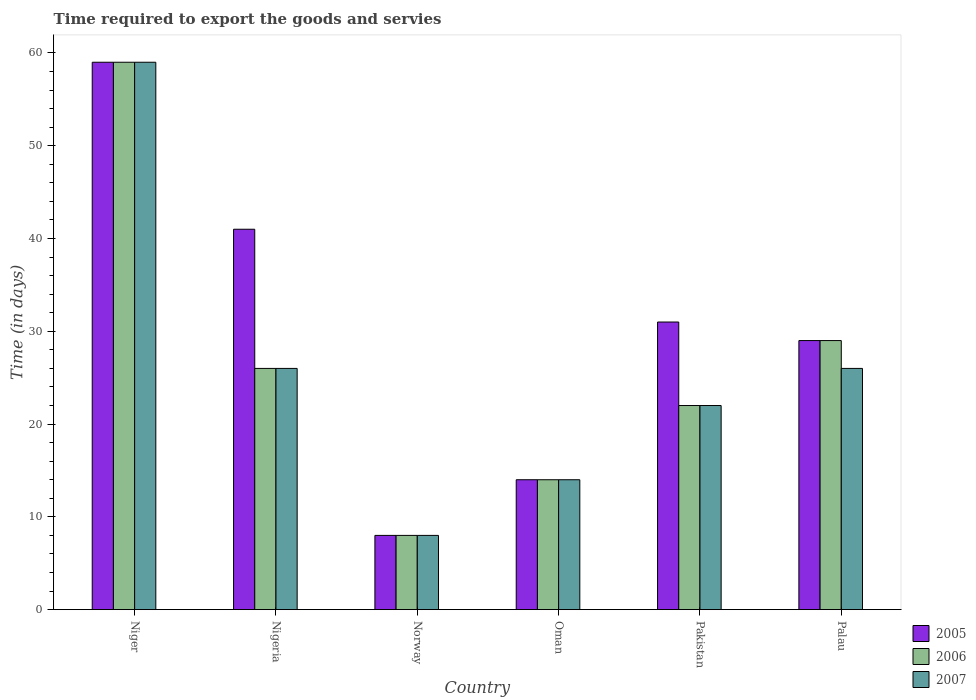How many different coloured bars are there?
Provide a short and direct response. 3. Are the number of bars per tick equal to the number of legend labels?
Ensure brevity in your answer.  Yes. Are the number of bars on each tick of the X-axis equal?
Keep it short and to the point. Yes. How many bars are there on the 4th tick from the right?
Your response must be concise. 3. What is the label of the 2nd group of bars from the left?
Your response must be concise. Nigeria. In which country was the number of days required to export the goods and services in 2006 maximum?
Provide a short and direct response. Niger. In which country was the number of days required to export the goods and services in 2006 minimum?
Provide a succinct answer. Norway. What is the total number of days required to export the goods and services in 2007 in the graph?
Your answer should be very brief. 155. What is the difference between the number of days required to export the goods and services in 2007 in Norway and that in Oman?
Provide a succinct answer. -6. What is the difference between the number of days required to export the goods and services in 2007 in Norway and the number of days required to export the goods and services in 2005 in Nigeria?
Make the answer very short. -33. What is the average number of days required to export the goods and services in 2006 per country?
Provide a succinct answer. 26.33. What is the difference between the number of days required to export the goods and services of/in 2006 and number of days required to export the goods and services of/in 2005 in Oman?
Provide a succinct answer. 0. In how many countries, is the number of days required to export the goods and services in 2005 greater than 22 days?
Offer a terse response. 4. What is the ratio of the number of days required to export the goods and services in 2007 in Oman to that in Pakistan?
Provide a succinct answer. 0.64. Is the number of days required to export the goods and services in 2007 in Niger less than that in Oman?
Offer a very short reply. No. Is the difference between the number of days required to export the goods and services in 2006 in Niger and Palau greater than the difference between the number of days required to export the goods and services in 2005 in Niger and Palau?
Make the answer very short. No. What is the difference between the highest and the second highest number of days required to export the goods and services in 2007?
Provide a short and direct response. -33. What is the difference between the highest and the lowest number of days required to export the goods and services in 2006?
Offer a terse response. 51. What does the 1st bar from the right in Palau represents?
Ensure brevity in your answer.  2007. Is it the case that in every country, the sum of the number of days required to export the goods and services in 2007 and number of days required to export the goods and services in 2005 is greater than the number of days required to export the goods and services in 2006?
Offer a very short reply. Yes. How many bars are there?
Ensure brevity in your answer.  18. How many countries are there in the graph?
Your answer should be very brief. 6. What is the difference between two consecutive major ticks on the Y-axis?
Offer a very short reply. 10. Are the values on the major ticks of Y-axis written in scientific E-notation?
Provide a succinct answer. No. Does the graph contain any zero values?
Give a very brief answer. No. Does the graph contain grids?
Give a very brief answer. No. Where does the legend appear in the graph?
Give a very brief answer. Bottom right. How are the legend labels stacked?
Offer a terse response. Vertical. What is the title of the graph?
Keep it short and to the point. Time required to export the goods and servies. Does "2002" appear as one of the legend labels in the graph?
Provide a short and direct response. No. What is the label or title of the X-axis?
Give a very brief answer. Country. What is the label or title of the Y-axis?
Give a very brief answer. Time (in days). What is the Time (in days) in 2005 in Niger?
Keep it short and to the point. 59. What is the Time (in days) of 2006 in Niger?
Give a very brief answer. 59. What is the Time (in days) in 2006 in Nigeria?
Give a very brief answer. 26. What is the Time (in days) of 2007 in Norway?
Your answer should be compact. 8. What is the Time (in days) of 2006 in Oman?
Your answer should be compact. 14. What is the Time (in days) in 2005 in Pakistan?
Offer a very short reply. 31. What is the Time (in days) of 2005 in Palau?
Your answer should be very brief. 29. Across all countries, what is the maximum Time (in days) of 2006?
Your response must be concise. 59. Across all countries, what is the minimum Time (in days) of 2005?
Your answer should be very brief. 8. Across all countries, what is the minimum Time (in days) of 2006?
Provide a short and direct response. 8. What is the total Time (in days) of 2005 in the graph?
Keep it short and to the point. 182. What is the total Time (in days) of 2006 in the graph?
Ensure brevity in your answer.  158. What is the total Time (in days) of 2007 in the graph?
Offer a very short reply. 155. What is the difference between the Time (in days) of 2006 in Niger and that in Nigeria?
Provide a short and direct response. 33. What is the difference between the Time (in days) of 2005 in Niger and that in Norway?
Ensure brevity in your answer.  51. What is the difference between the Time (in days) of 2006 in Niger and that in Norway?
Provide a short and direct response. 51. What is the difference between the Time (in days) of 2006 in Niger and that in Oman?
Your answer should be compact. 45. What is the difference between the Time (in days) in 2005 in Niger and that in Pakistan?
Make the answer very short. 28. What is the difference between the Time (in days) in 2006 in Niger and that in Pakistan?
Offer a very short reply. 37. What is the difference between the Time (in days) of 2007 in Niger and that in Pakistan?
Make the answer very short. 37. What is the difference between the Time (in days) in 2006 in Niger and that in Palau?
Provide a succinct answer. 30. What is the difference between the Time (in days) in 2005 in Nigeria and that in Norway?
Your response must be concise. 33. What is the difference between the Time (in days) in 2006 in Nigeria and that in Norway?
Give a very brief answer. 18. What is the difference between the Time (in days) of 2007 in Nigeria and that in Norway?
Keep it short and to the point. 18. What is the difference between the Time (in days) in 2005 in Nigeria and that in Oman?
Offer a very short reply. 27. What is the difference between the Time (in days) of 2005 in Nigeria and that in Pakistan?
Your answer should be compact. 10. What is the difference between the Time (in days) of 2006 in Nigeria and that in Pakistan?
Offer a terse response. 4. What is the difference between the Time (in days) of 2007 in Nigeria and that in Pakistan?
Ensure brevity in your answer.  4. What is the difference between the Time (in days) of 2006 in Nigeria and that in Palau?
Your response must be concise. -3. What is the difference between the Time (in days) in 2005 in Norway and that in Oman?
Offer a very short reply. -6. What is the difference between the Time (in days) in 2006 in Norway and that in Oman?
Offer a terse response. -6. What is the difference between the Time (in days) of 2007 in Norway and that in Oman?
Provide a short and direct response. -6. What is the difference between the Time (in days) in 2006 in Norway and that in Pakistan?
Offer a very short reply. -14. What is the difference between the Time (in days) of 2005 in Norway and that in Palau?
Give a very brief answer. -21. What is the difference between the Time (in days) in 2007 in Norway and that in Palau?
Provide a short and direct response. -18. What is the difference between the Time (in days) of 2006 in Oman and that in Palau?
Your answer should be compact. -15. What is the difference between the Time (in days) of 2006 in Pakistan and that in Palau?
Provide a short and direct response. -7. What is the difference between the Time (in days) in 2007 in Pakistan and that in Palau?
Provide a short and direct response. -4. What is the difference between the Time (in days) in 2006 in Niger and the Time (in days) in 2007 in Nigeria?
Ensure brevity in your answer.  33. What is the difference between the Time (in days) of 2005 in Niger and the Time (in days) of 2006 in Norway?
Your response must be concise. 51. What is the difference between the Time (in days) in 2006 in Niger and the Time (in days) in 2007 in Norway?
Provide a short and direct response. 51. What is the difference between the Time (in days) of 2005 in Niger and the Time (in days) of 2006 in Oman?
Ensure brevity in your answer.  45. What is the difference between the Time (in days) in 2005 in Niger and the Time (in days) in 2007 in Oman?
Offer a terse response. 45. What is the difference between the Time (in days) of 2005 in Niger and the Time (in days) of 2007 in Pakistan?
Your response must be concise. 37. What is the difference between the Time (in days) of 2005 in Niger and the Time (in days) of 2007 in Palau?
Provide a succinct answer. 33. What is the difference between the Time (in days) of 2005 in Nigeria and the Time (in days) of 2006 in Norway?
Provide a short and direct response. 33. What is the difference between the Time (in days) in 2005 in Nigeria and the Time (in days) in 2007 in Norway?
Offer a very short reply. 33. What is the difference between the Time (in days) of 2006 in Nigeria and the Time (in days) of 2007 in Norway?
Make the answer very short. 18. What is the difference between the Time (in days) of 2005 in Nigeria and the Time (in days) of 2007 in Pakistan?
Your answer should be very brief. 19. What is the difference between the Time (in days) of 2005 in Nigeria and the Time (in days) of 2007 in Palau?
Your answer should be compact. 15. What is the difference between the Time (in days) of 2006 in Nigeria and the Time (in days) of 2007 in Palau?
Keep it short and to the point. 0. What is the difference between the Time (in days) of 2005 in Norway and the Time (in days) of 2007 in Oman?
Offer a very short reply. -6. What is the difference between the Time (in days) of 2005 in Norway and the Time (in days) of 2007 in Pakistan?
Your answer should be compact. -14. What is the difference between the Time (in days) of 2006 in Norway and the Time (in days) of 2007 in Pakistan?
Give a very brief answer. -14. What is the difference between the Time (in days) of 2005 in Norway and the Time (in days) of 2007 in Palau?
Your response must be concise. -18. What is the difference between the Time (in days) in 2005 in Oman and the Time (in days) in 2006 in Pakistan?
Offer a very short reply. -8. What is the difference between the Time (in days) in 2005 in Oman and the Time (in days) in 2007 in Pakistan?
Your answer should be compact. -8. What is the difference between the Time (in days) in 2006 in Oman and the Time (in days) in 2007 in Pakistan?
Offer a very short reply. -8. What is the difference between the Time (in days) in 2005 in Oman and the Time (in days) in 2006 in Palau?
Provide a succinct answer. -15. What is the difference between the Time (in days) in 2006 in Oman and the Time (in days) in 2007 in Palau?
Offer a terse response. -12. What is the difference between the Time (in days) of 2005 in Pakistan and the Time (in days) of 2006 in Palau?
Provide a succinct answer. 2. What is the difference between the Time (in days) of 2006 in Pakistan and the Time (in days) of 2007 in Palau?
Make the answer very short. -4. What is the average Time (in days) in 2005 per country?
Give a very brief answer. 30.33. What is the average Time (in days) of 2006 per country?
Offer a terse response. 26.33. What is the average Time (in days) of 2007 per country?
Provide a succinct answer. 25.83. What is the difference between the Time (in days) of 2005 and Time (in days) of 2006 in Niger?
Offer a terse response. 0. What is the difference between the Time (in days) of 2005 and Time (in days) of 2007 in Niger?
Your answer should be very brief. 0. What is the difference between the Time (in days) of 2006 and Time (in days) of 2007 in Niger?
Your answer should be very brief. 0. What is the difference between the Time (in days) of 2005 and Time (in days) of 2006 in Nigeria?
Keep it short and to the point. 15. What is the difference between the Time (in days) of 2005 and Time (in days) of 2007 in Nigeria?
Offer a terse response. 15. What is the difference between the Time (in days) of 2005 and Time (in days) of 2006 in Norway?
Provide a succinct answer. 0. What is the difference between the Time (in days) in 2005 and Time (in days) in 2007 in Norway?
Offer a very short reply. 0. What is the difference between the Time (in days) of 2006 and Time (in days) of 2007 in Norway?
Offer a very short reply. 0. What is the difference between the Time (in days) in 2005 and Time (in days) in 2007 in Oman?
Make the answer very short. 0. What is the difference between the Time (in days) in 2005 and Time (in days) in 2006 in Pakistan?
Ensure brevity in your answer.  9. What is the difference between the Time (in days) in 2005 and Time (in days) in 2007 in Pakistan?
Your answer should be very brief. 9. What is the ratio of the Time (in days) of 2005 in Niger to that in Nigeria?
Keep it short and to the point. 1.44. What is the ratio of the Time (in days) of 2006 in Niger to that in Nigeria?
Your answer should be very brief. 2.27. What is the ratio of the Time (in days) in 2007 in Niger to that in Nigeria?
Provide a short and direct response. 2.27. What is the ratio of the Time (in days) of 2005 in Niger to that in Norway?
Your response must be concise. 7.38. What is the ratio of the Time (in days) of 2006 in Niger to that in Norway?
Keep it short and to the point. 7.38. What is the ratio of the Time (in days) in 2007 in Niger to that in Norway?
Your answer should be very brief. 7.38. What is the ratio of the Time (in days) of 2005 in Niger to that in Oman?
Make the answer very short. 4.21. What is the ratio of the Time (in days) of 2006 in Niger to that in Oman?
Offer a terse response. 4.21. What is the ratio of the Time (in days) in 2007 in Niger to that in Oman?
Provide a succinct answer. 4.21. What is the ratio of the Time (in days) of 2005 in Niger to that in Pakistan?
Make the answer very short. 1.9. What is the ratio of the Time (in days) of 2006 in Niger to that in Pakistan?
Your response must be concise. 2.68. What is the ratio of the Time (in days) of 2007 in Niger to that in Pakistan?
Provide a short and direct response. 2.68. What is the ratio of the Time (in days) of 2005 in Niger to that in Palau?
Make the answer very short. 2.03. What is the ratio of the Time (in days) in 2006 in Niger to that in Palau?
Give a very brief answer. 2.03. What is the ratio of the Time (in days) in 2007 in Niger to that in Palau?
Keep it short and to the point. 2.27. What is the ratio of the Time (in days) in 2005 in Nigeria to that in Norway?
Offer a very short reply. 5.12. What is the ratio of the Time (in days) of 2005 in Nigeria to that in Oman?
Offer a very short reply. 2.93. What is the ratio of the Time (in days) of 2006 in Nigeria to that in Oman?
Make the answer very short. 1.86. What is the ratio of the Time (in days) of 2007 in Nigeria to that in Oman?
Provide a succinct answer. 1.86. What is the ratio of the Time (in days) of 2005 in Nigeria to that in Pakistan?
Offer a very short reply. 1.32. What is the ratio of the Time (in days) in 2006 in Nigeria to that in Pakistan?
Provide a succinct answer. 1.18. What is the ratio of the Time (in days) in 2007 in Nigeria to that in Pakistan?
Offer a very short reply. 1.18. What is the ratio of the Time (in days) of 2005 in Nigeria to that in Palau?
Provide a short and direct response. 1.41. What is the ratio of the Time (in days) of 2006 in Nigeria to that in Palau?
Keep it short and to the point. 0.9. What is the ratio of the Time (in days) of 2007 in Nigeria to that in Palau?
Offer a very short reply. 1. What is the ratio of the Time (in days) in 2005 in Norway to that in Oman?
Keep it short and to the point. 0.57. What is the ratio of the Time (in days) of 2005 in Norway to that in Pakistan?
Provide a succinct answer. 0.26. What is the ratio of the Time (in days) in 2006 in Norway to that in Pakistan?
Your answer should be compact. 0.36. What is the ratio of the Time (in days) of 2007 in Norway to that in Pakistan?
Your answer should be very brief. 0.36. What is the ratio of the Time (in days) of 2005 in Norway to that in Palau?
Your answer should be very brief. 0.28. What is the ratio of the Time (in days) in 2006 in Norway to that in Palau?
Give a very brief answer. 0.28. What is the ratio of the Time (in days) in 2007 in Norway to that in Palau?
Offer a very short reply. 0.31. What is the ratio of the Time (in days) of 2005 in Oman to that in Pakistan?
Keep it short and to the point. 0.45. What is the ratio of the Time (in days) in 2006 in Oman to that in Pakistan?
Offer a terse response. 0.64. What is the ratio of the Time (in days) in 2007 in Oman to that in Pakistan?
Your answer should be very brief. 0.64. What is the ratio of the Time (in days) in 2005 in Oman to that in Palau?
Offer a terse response. 0.48. What is the ratio of the Time (in days) of 2006 in Oman to that in Palau?
Offer a terse response. 0.48. What is the ratio of the Time (in days) of 2007 in Oman to that in Palau?
Give a very brief answer. 0.54. What is the ratio of the Time (in days) in 2005 in Pakistan to that in Palau?
Keep it short and to the point. 1.07. What is the ratio of the Time (in days) of 2006 in Pakistan to that in Palau?
Your answer should be compact. 0.76. What is the ratio of the Time (in days) in 2007 in Pakistan to that in Palau?
Your answer should be very brief. 0.85. What is the difference between the highest and the second highest Time (in days) in 2006?
Provide a short and direct response. 30. What is the difference between the highest and the second highest Time (in days) in 2007?
Provide a succinct answer. 33. What is the difference between the highest and the lowest Time (in days) of 2005?
Offer a very short reply. 51. What is the difference between the highest and the lowest Time (in days) in 2007?
Your answer should be compact. 51. 